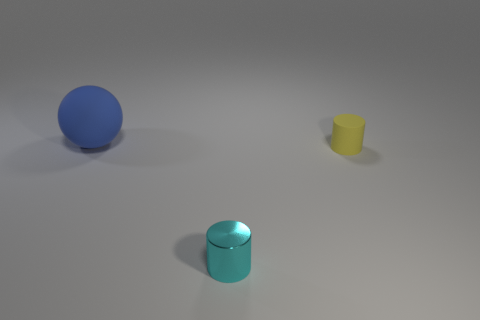Is there anything else that is made of the same material as the cyan object?
Give a very brief answer. No. Is the number of small yellow rubber things in front of the small cyan object greater than the number of tiny matte cylinders?
Make the answer very short. No. There is a tiny metal object; is it the same shape as the small object that is behind the shiny object?
Keep it short and to the point. Yes. Is there anything else that has the same size as the blue object?
Keep it short and to the point. No. There is another object that is the same shape as the metallic object; what is its size?
Your answer should be compact. Small. Are there more tiny cyan things than big gray matte cylinders?
Your answer should be very brief. Yes. Do the yellow thing and the cyan thing have the same shape?
Make the answer very short. Yes. What is the thing right of the tiny object in front of the small yellow matte cylinder made of?
Make the answer very short. Rubber. Does the cyan cylinder have the same size as the blue matte thing?
Provide a succinct answer. No. There is a small cylinder in front of the small yellow matte cylinder; is there a small cyan cylinder that is behind it?
Give a very brief answer. No. 